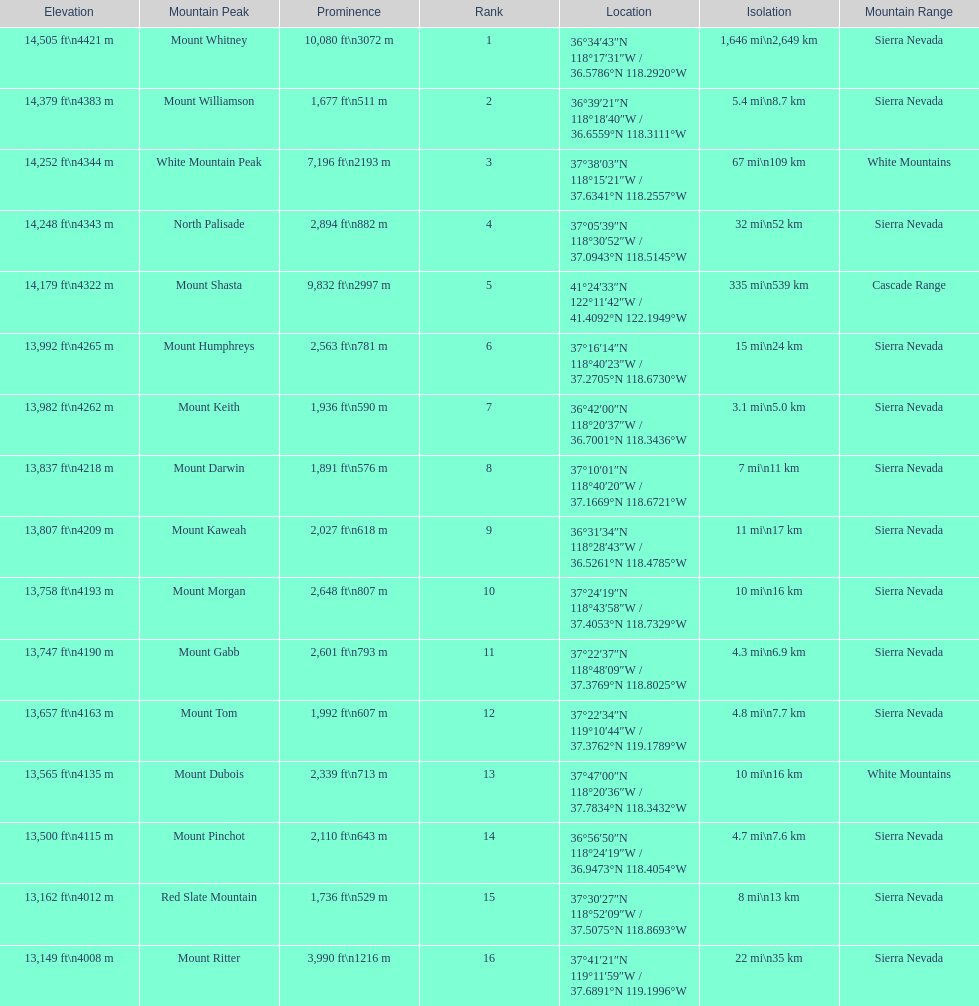Which mountain peak has the most isolation? Mount Whitney. 